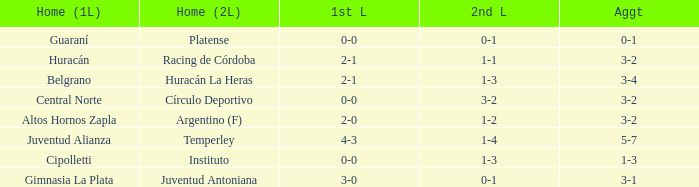What was the total score with a 1-2 second leg score? 3-2. 